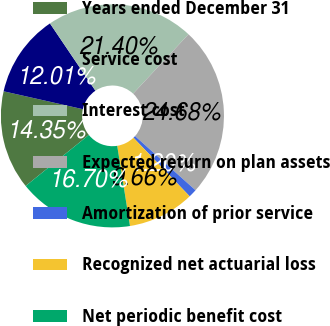Convert chart to OTSL. <chart><loc_0><loc_0><loc_500><loc_500><pie_chart><fcel>Years ended December 31<fcel>Service cost<fcel>Interest cost<fcel>Expected return on plan assets<fcel>Amortization of prior service<fcel>Recognized net actuarial loss<fcel>Net periodic benefit cost<nl><fcel>14.35%<fcel>12.01%<fcel>21.4%<fcel>24.68%<fcel>1.2%<fcel>9.66%<fcel>16.7%<nl></chart> 